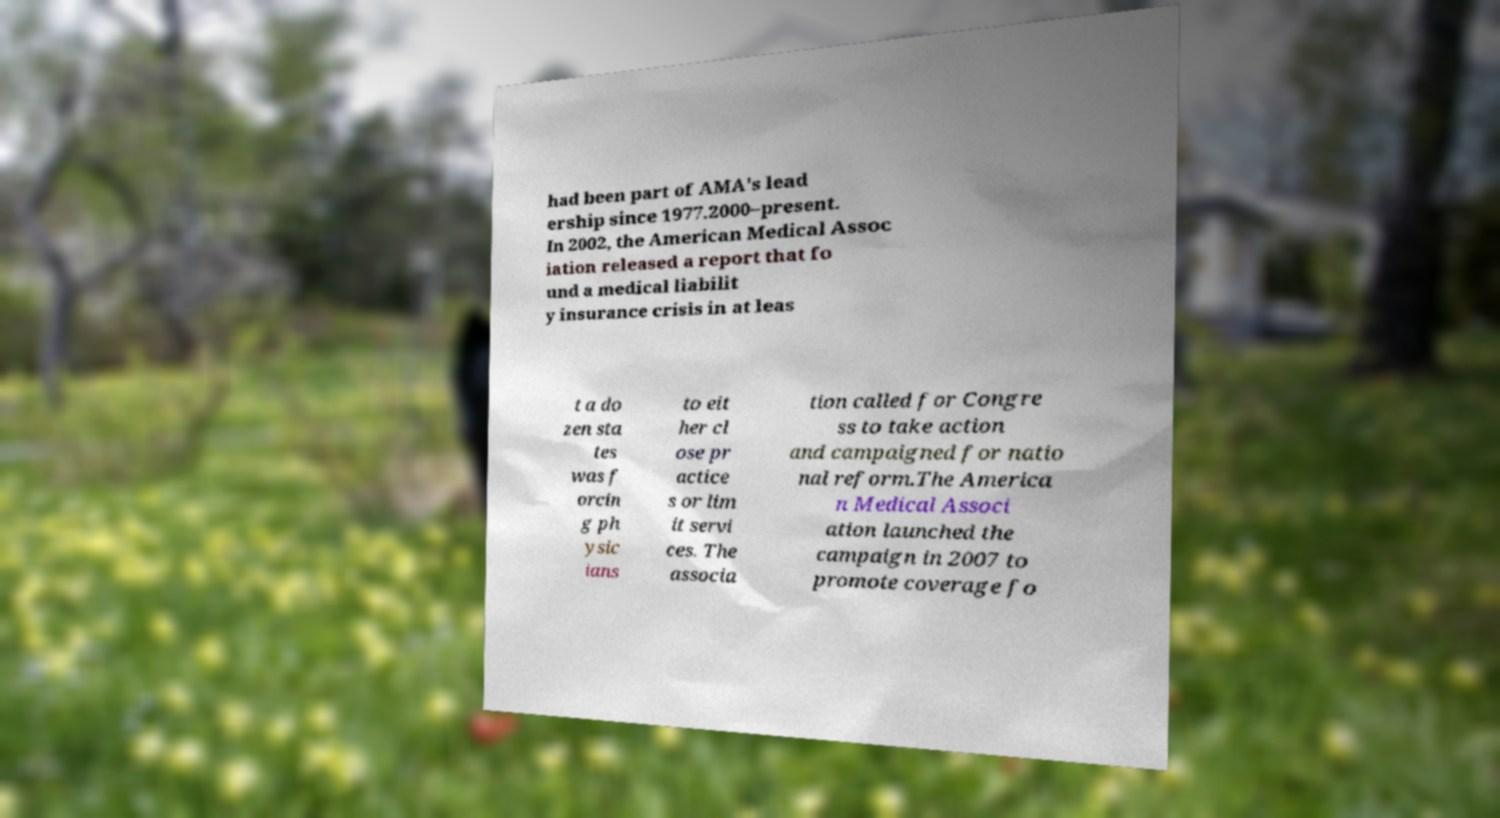What messages or text are displayed in this image? I need them in a readable, typed format. had been part of AMA's lead ership since 1977.2000–present. In 2002, the American Medical Assoc iation released a report that fo und a medical liabilit y insurance crisis in at leas t a do zen sta tes was f orcin g ph ysic ians to eit her cl ose pr actice s or lim it servi ces. The associa tion called for Congre ss to take action and campaigned for natio nal reform.The America n Medical Associ ation launched the campaign in 2007 to promote coverage fo 